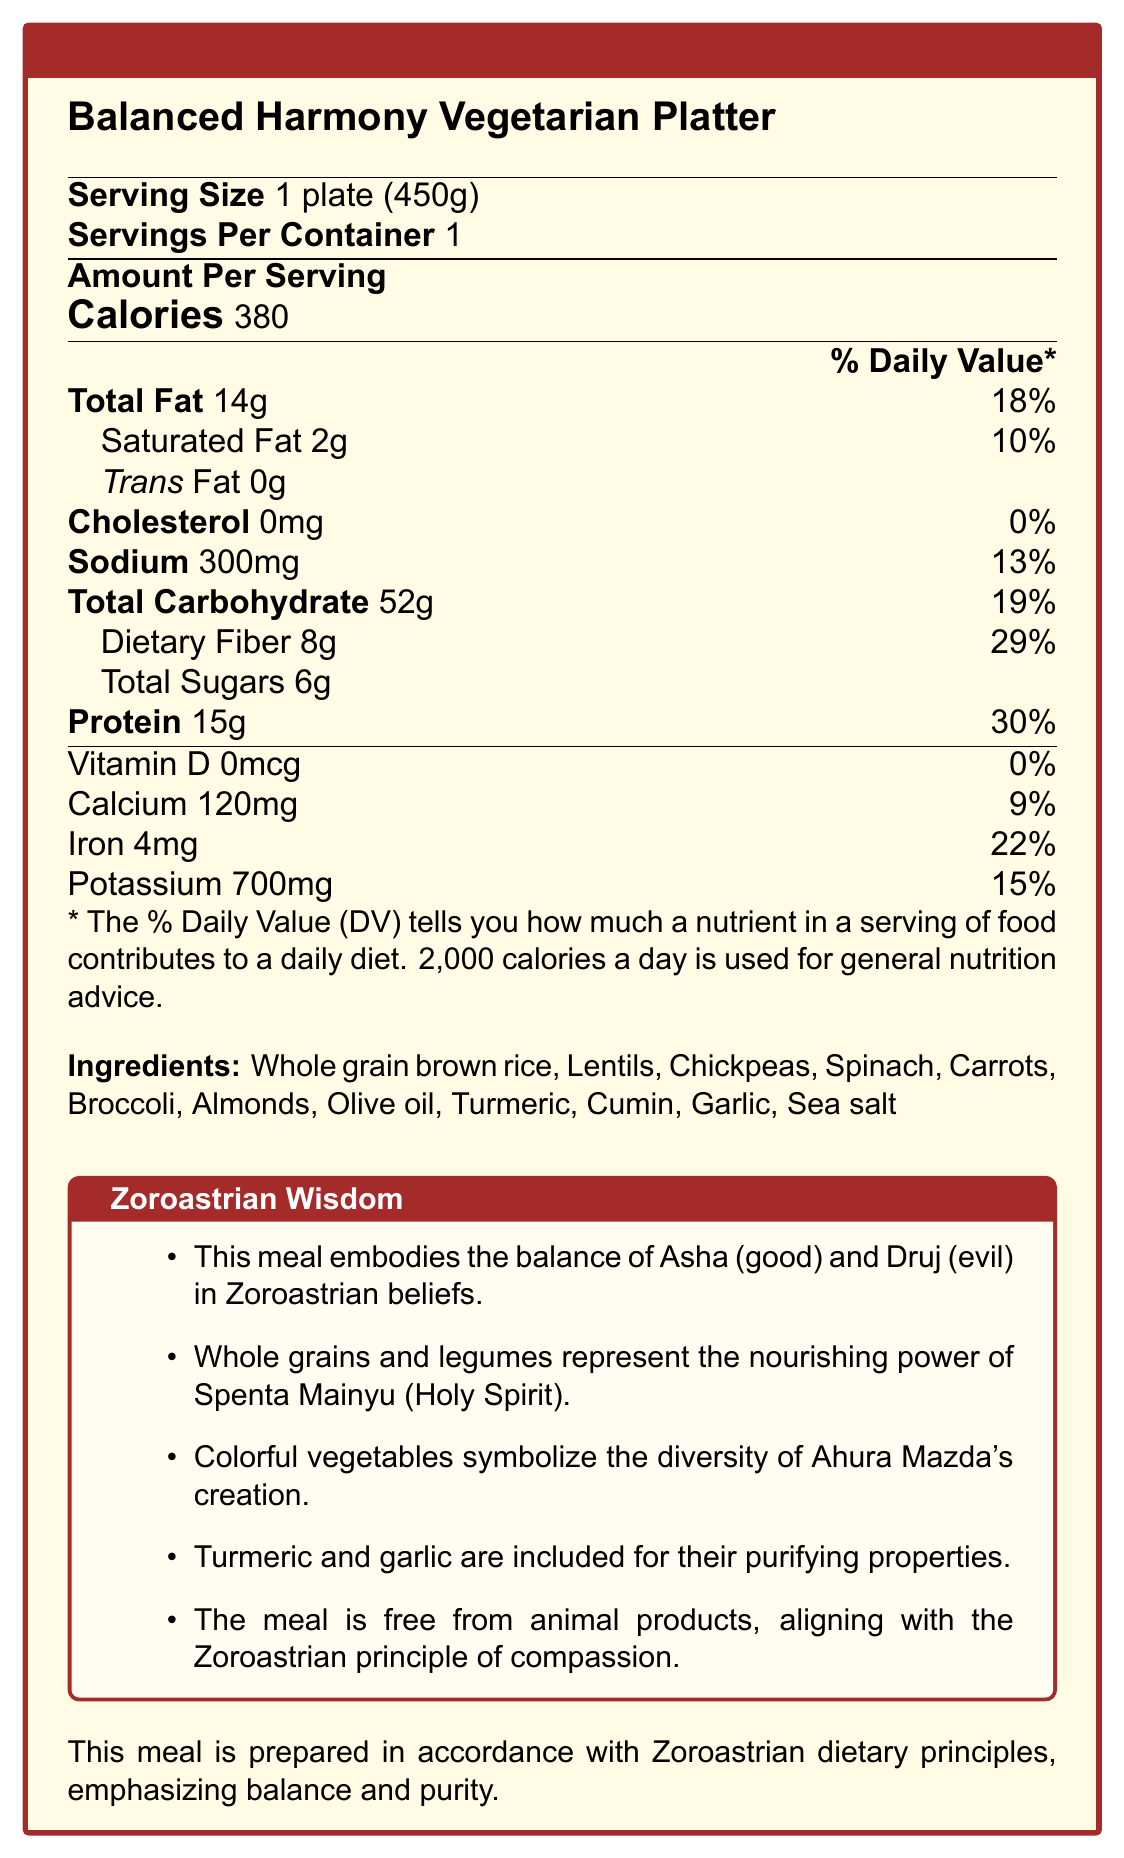What is the serving size of the Balanced Harmony Vegetarian Platter? The serving size is indicated directly in the document as "1 plate (450g)".
Answer: 1 plate (450g) What are the main ingredients in the Balanced Harmony Vegetarian Platter? The list of main ingredients is provided in the document under the "Ingredients" section.
Answer: Whole grain brown rice, Lentils, Chickpeas, Spinach, Carrots, Broccoli, Almonds, Olive oil, Turmeric, Cumin, Garlic, Sea salt How many calories are there per serving of the Balanced Harmony Vegetarian Platter? The document lists "Calories: 380" under the Amount Per Serving section.
Answer: 380 calories Does this meal contain any cholesterol? The document explicitly states that the cholesterol content is 0mg, with a daily value percentage of 0%.
Answer: No What percentage of the daily value for iron is provided by one serving of this meal? The document indicates that one serving contains 22% of the daily value for iron.
Answer: 22% Which nutrient in this meal has the highest daily value percentage? A. Total Fat B. Protein C. Cholesterol D. Dietary Fiber Protein, with a daily value percentage of 30%, has the highest daily value compared to the other options.
Answer: B What do the colorful vegetables in this meal symbolize according to Zoroastrian beliefs? A. Spiritual purity B. Compassion for all living beings C. Diversity of Ahura Mazda's creation D. Nourishing power of Spenta Mainyu The colorful vegetables symbolize the diversity of Ahura Mazda's creation as per the Zoroastrian notes provided.
Answer: C Can the daily sugar intake be determined from this document? The document does not provide the daily value percentage for total sugars, making it impossible to determine the daily sugar intake.
Answer: No Is the meal free from animal products? The document explicitly states that the meal is free from animal products, aligning with the Zoroastrian principle of compassion.
Answer: Yes Summarize the main idea of the document. The document includes essential nutritional facts, a list of ingredients, Zoroastrian wisdom emphasizing the balance of good and evil, and the healthful and spiritual benefits of the meal.
Answer: The document provides detailed nutritional information for the Balanced Harmony Vegetarian Platter, highlighting its ingredients, nutritional values, and Zoroastrian notes about the spiritual significance of the ingredients. The emphasis is on a meal that balances good (Asha) and evil (Druj) and promotes physical and spiritual well-being according to Zoroastrian dietary principles. What do turmeric and garlic represent in the Zoroastrian wisdom about this meal? The document mentions that turmeric and garlic are included for their purifying properties and help ward off negative influences and promote spiritual purity.
Answer: Purifying properties 